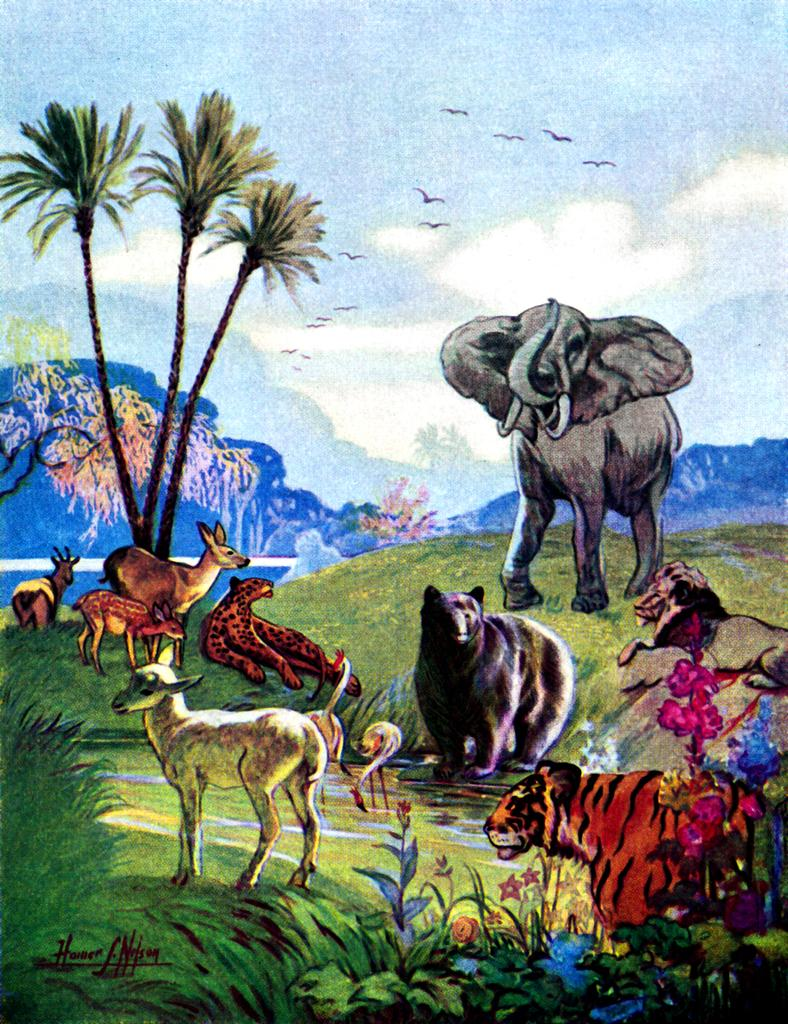What types of living organisms are included in the painting? The painting contains animals, birds, and plants. What is the landscape like in the painting? There is grassy land depicted in the painting. Are there any specific plants shown in the painting? Yes, flowers are present in the painting. What is visible at the top of the painting? The sky is visible at the top of the painting, and there are clouds in the sky. What advice is the duck giving to the other animals in the painting? There is no duck present in the painting, and therefore no advice can be given. What type of weather is depicted in the painting? The painting does not depict any specific weather conditions; it only shows clouds in the sky. 